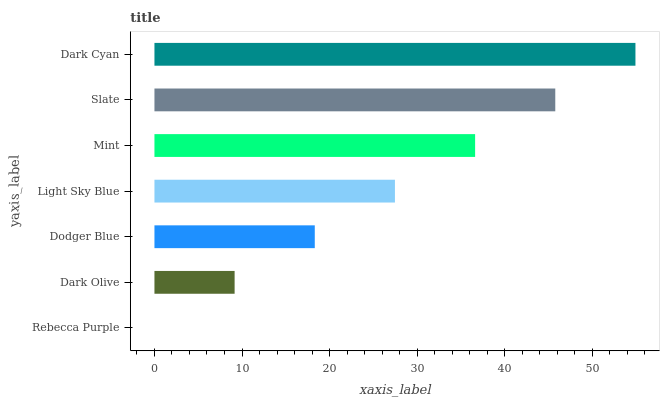Is Rebecca Purple the minimum?
Answer yes or no. Yes. Is Dark Cyan the maximum?
Answer yes or no. Yes. Is Dark Olive the minimum?
Answer yes or no. No. Is Dark Olive the maximum?
Answer yes or no. No. Is Dark Olive greater than Rebecca Purple?
Answer yes or no. Yes. Is Rebecca Purple less than Dark Olive?
Answer yes or no. Yes. Is Rebecca Purple greater than Dark Olive?
Answer yes or no. No. Is Dark Olive less than Rebecca Purple?
Answer yes or no. No. Is Light Sky Blue the high median?
Answer yes or no. Yes. Is Light Sky Blue the low median?
Answer yes or no. Yes. Is Dodger Blue the high median?
Answer yes or no. No. Is Rebecca Purple the low median?
Answer yes or no. No. 